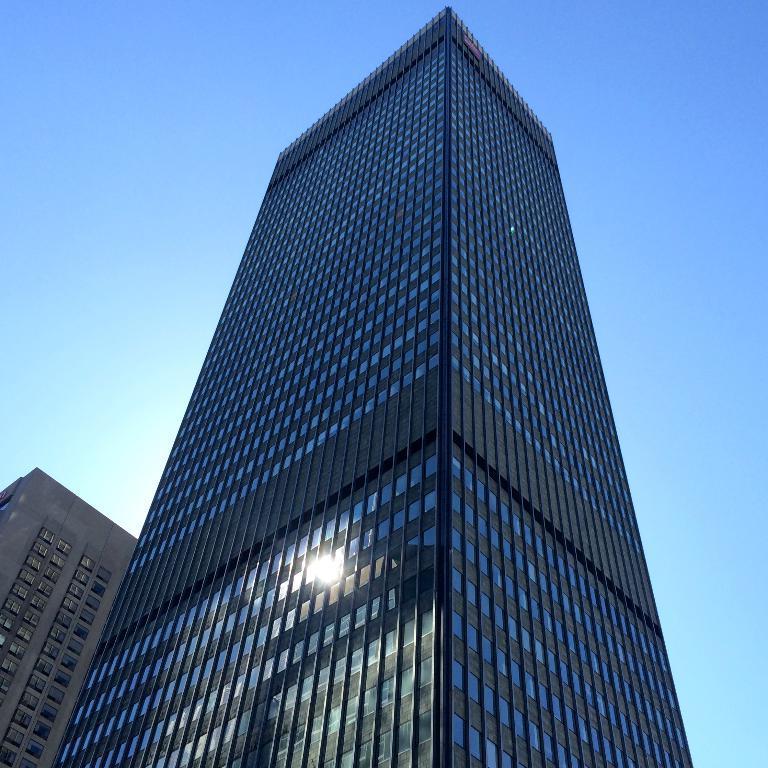In one or two sentences, can you explain what this image depicts? In this picture I can see buildings with glass doors, and in the background there is the sky. 